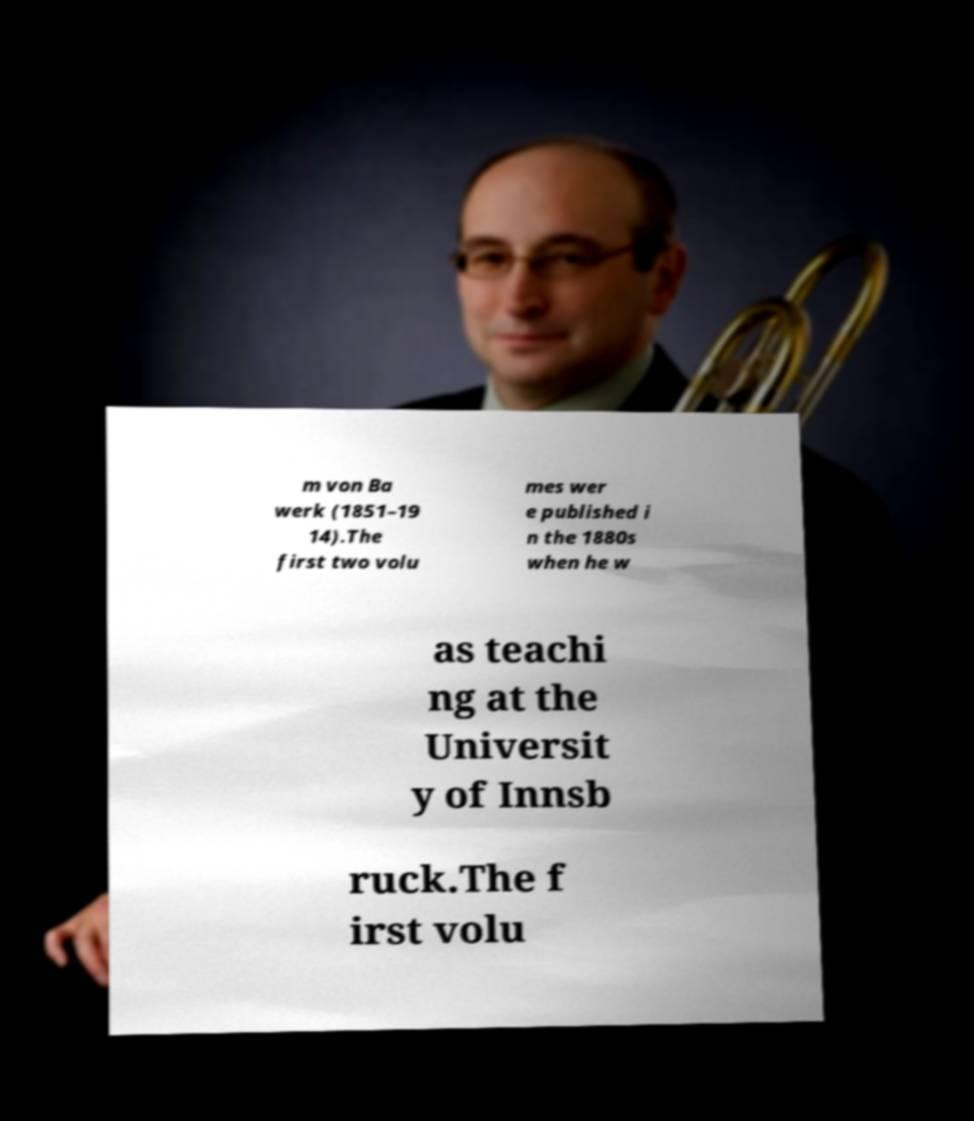For documentation purposes, I need the text within this image transcribed. Could you provide that? m von Ba werk (1851–19 14).The first two volu mes wer e published i n the 1880s when he w as teachi ng at the Universit y of Innsb ruck.The f irst volu 